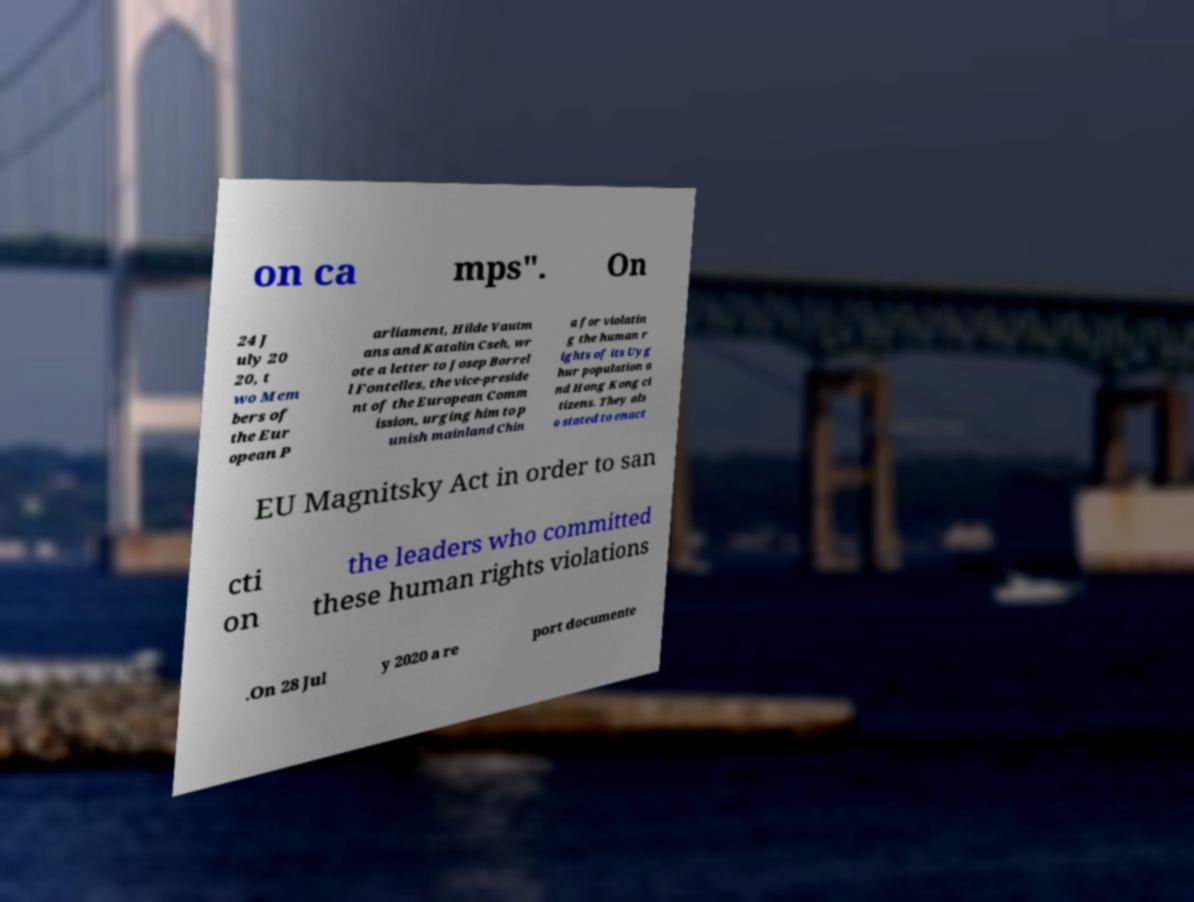Please read and relay the text visible in this image. What does it say? on ca mps". On 24 J uly 20 20, t wo Mem bers of the Eur opean P arliament, Hilde Vautm ans and Katalin Cseh, wr ote a letter to Josep Borrel l Fontelles, the vice-preside nt of the European Comm ission, urging him to p unish mainland Chin a for violatin g the human r ights of its Uyg hur population a nd Hong Kong ci tizens. They als o stated to enact EU Magnitsky Act in order to san cti on the leaders who committed these human rights violations .On 28 Jul y 2020 a re port documente 